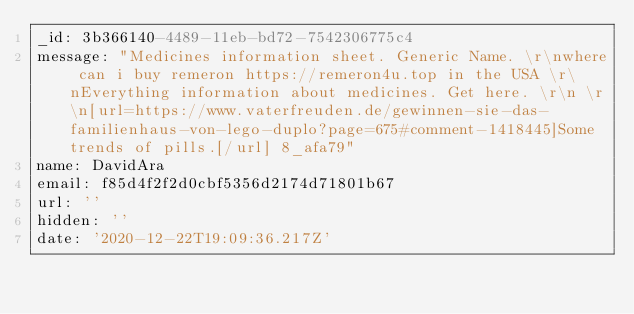Convert code to text. <code><loc_0><loc_0><loc_500><loc_500><_YAML_>_id: 3b366140-4489-11eb-bd72-7542306775c4
message: "Medicines information sheet. Generic Name. \r\nwhere can i buy remeron https://remeron4u.top in the USA \r\nEverything information about medicines. Get here. \r\n \r\n[url=https://www.vaterfreuden.de/gewinnen-sie-das-familienhaus-von-lego-duplo?page=675#comment-1418445]Some trends of pills.[/url] 8_afa79"
name: DavidAra
email: f85d4f2f2d0cbf5356d2174d71801b67
url: ''
hidden: ''
date: '2020-12-22T19:09:36.217Z'
</code> 